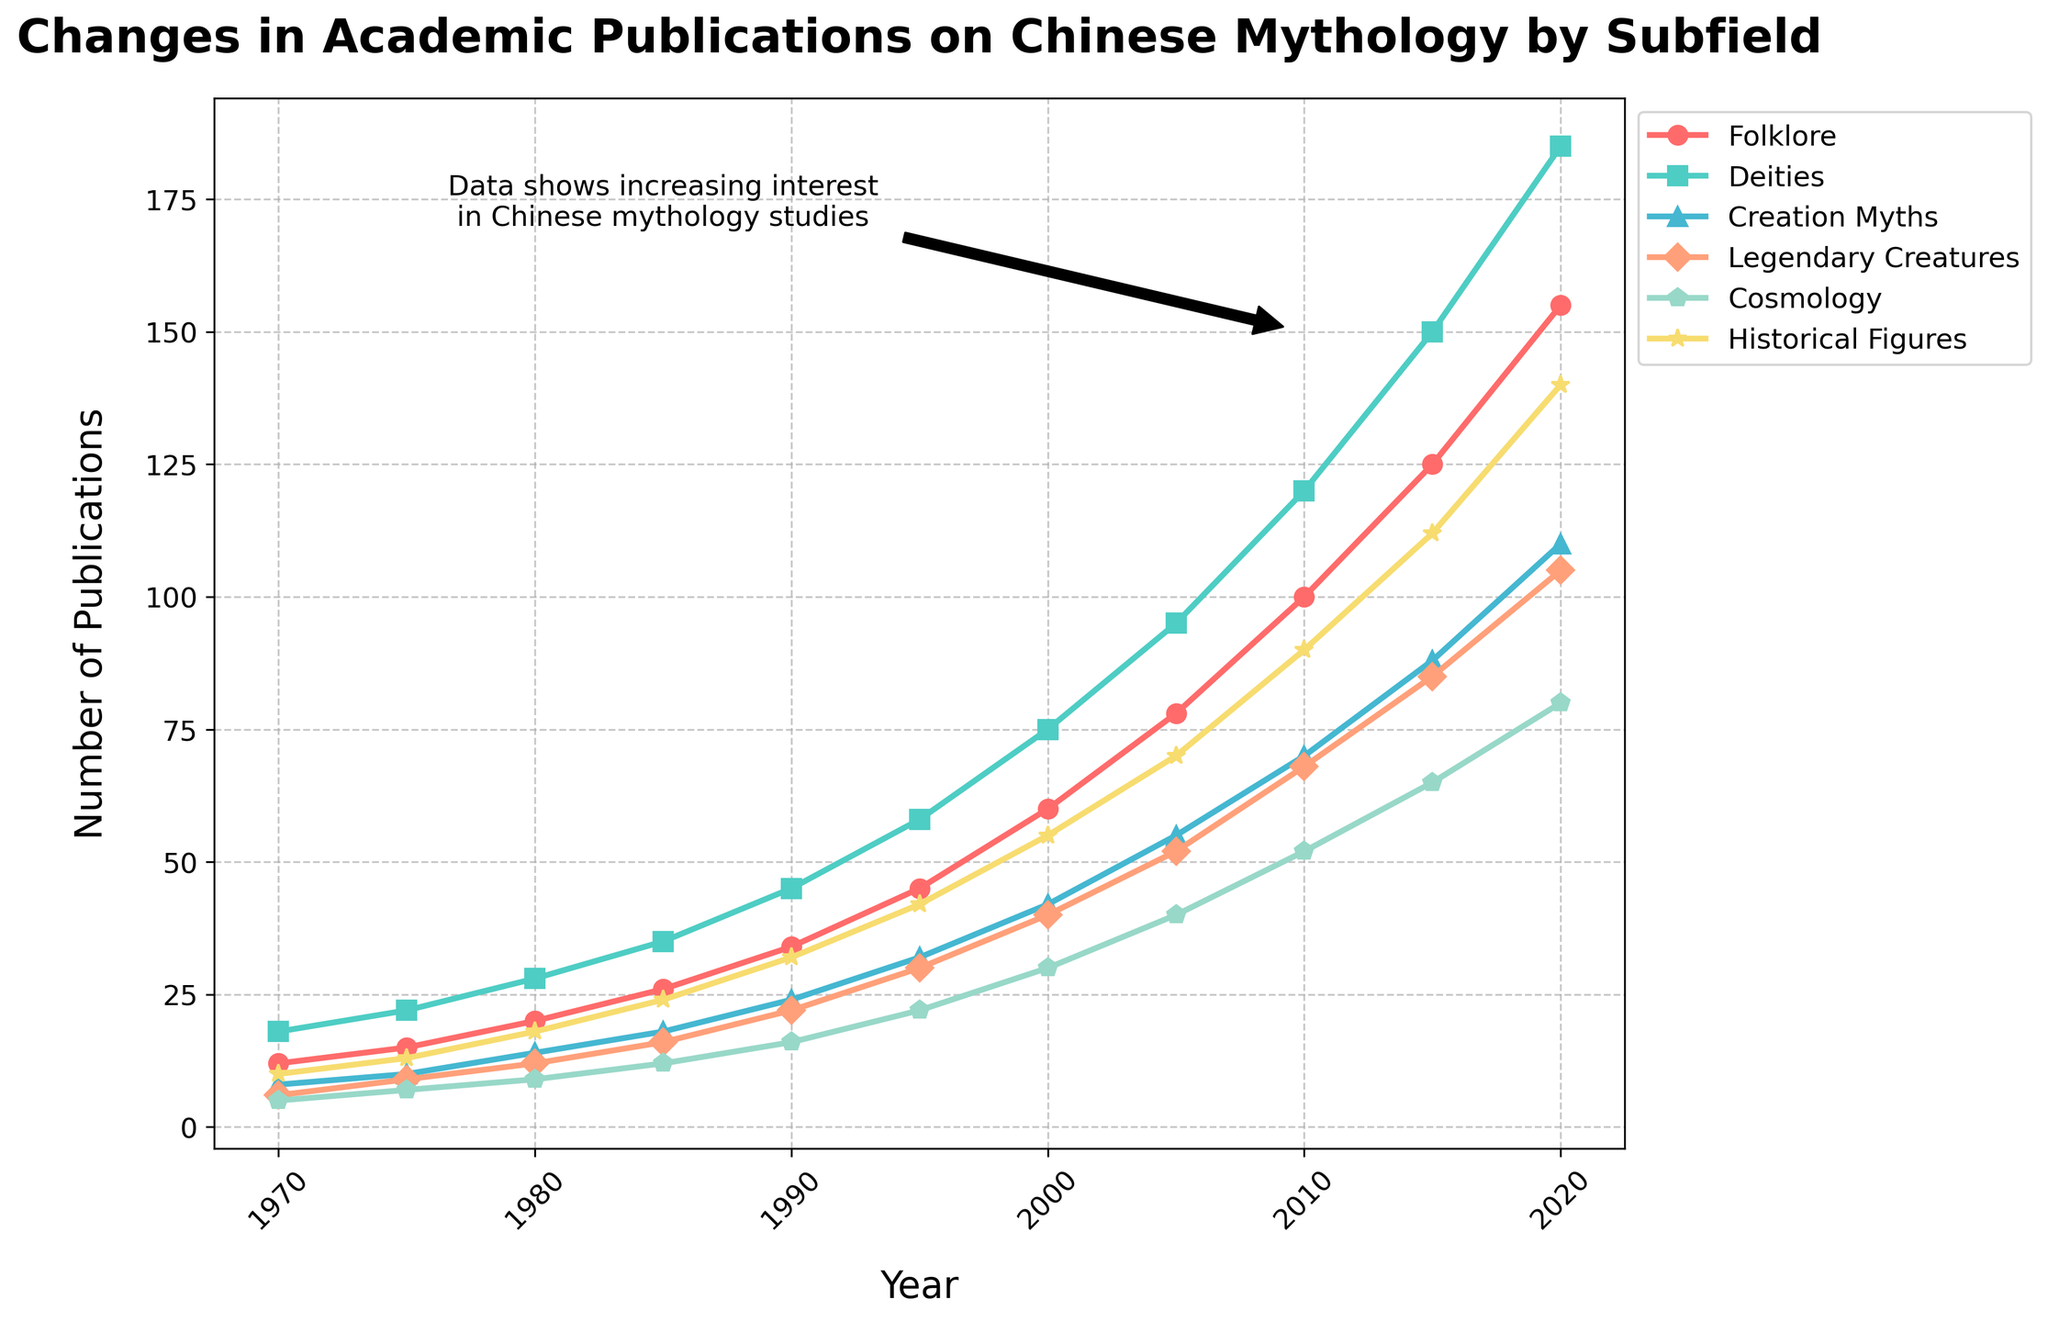What is the total number of publications on Deities in 2005 and 2010? Add the number of publications on Deities in 2005 (95) and 2010 (120). 95 + 120 = 215
Answer: 215 Which subfield had the highest number of publications in 2020? Compare the values for each subfield in 2020: Folklore (155), Deities (185), Creation Myths (110), Legendary Creatures (105), Cosmology (80), and Historical Figures (140). Deities had the highest number.
Answer: Deities Between 1990 and 2020, which subfield saw the greatest increase in the number of publications? Calculate the increase for each subfield from 1990 to 2020: Folklore (155-34=121), Deities (185-45=140), Creation Myths (110-24=86), Legendary Creatures (105-22=83), Cosmology (80-16=64), Historical Figures (140-32=108). Deities saw the greatest increase.
Answer: Deities What is the average number of publications on Creation Myths from 2000 to 2020? Sum the number of publications on Creation Myths from 2000 (42), 2005 (55), 2010 (70), 2015 (88), and 2020 (110), then divide by 5. (42 + 55 + 70 + 88 + 110) / 5 = 365 / 5 = 73
Answer: 73 Which subfield had fewer publications than Folklore in 2015? Compare the number of publications in 2015 for each subfield with Folklore (125): Deities (150), Creation Myths (88), Legendary Creatures (85), Cosmology (65), Historical Figures (112). Creation Myths, Legendary Creatures, and Cosmology had fewer publications.
Answer: Creation Myths, Legendary Creatures, Cosmology How did the number of publications on Historical Figures change from 1970 to 1995? Subtract the number of publications in 1970 (10) from the number in 1995 (42). 42 - 10 = 32
Answer: 32 Between 1970 and 2000, which subfield saw the smallest cumulative number of publications? Sum the number of publications for all subfields from 1970 to 2000 and compare: Folklore (12+15+20+26+34+45+60=212), Deities (18+22+28+35+45+58+75=281), Creation Myths (8+10+14+18+24+32+42=148), Legendary Creatures (6+9+12+16+22+30+40=135), Cosmology (5+7+9+12+16+22+30=101), Historical Figures (10+13+18+24+32+42+55=194). Cosmology had the smallest cumulative total.
Answer: Cosmology In which year did Folklore publications first reach a number greater than 100? Check the number of Folklore publications for each year until it surpasses 100. Folklore publications first exceeded 100 in 2010 (100), but since the greater-than condition is asked, 2015 (125) is the answer.
Answer: 2015 